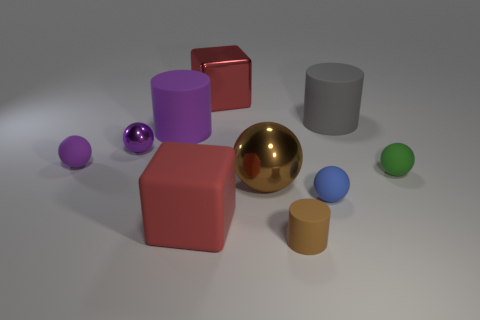Subtract all purple rubber spheres. How many spheres are left? 4 Subtract all blue spheres. How many spheres are left? 4 Subtract all yellow balls. Subtract all blue cylinders. How many balls are left? 5 Subtract all cylinders. How many objects are left? 7 Add 2 big purple balls. How many big purple balls exist? 2 Subtract 1 purple balls. How many objects are left? 9 Subtract all small green objects. Subtract all large brown rubber cubes. How many objects are left? 9 Add 5 big blocks. How many big blocks are left? 7 